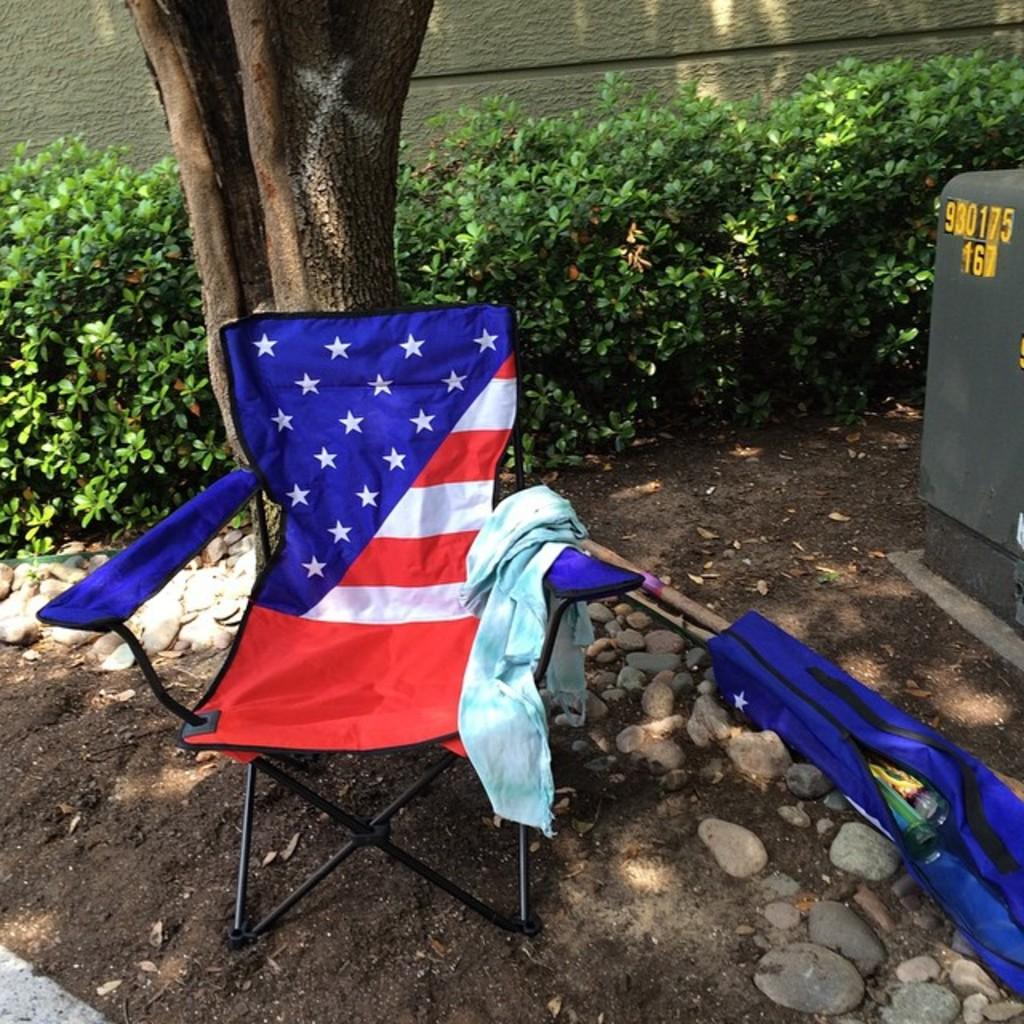What is located in the foreground of the image? In the foreground of the image, there is a chair, cloth, a box, plants, a tree trunk, and a wall. Can you describe the objects in the foreground? The chair is likely for sitting, the cloth could be a tablecloth or fabric, the box is a container, the plants are living organisms, the tree trunk is a part of a tree, and the wall is a vertical structure. What might be the setting of the image? The image may have been taken in a garden, as there are plants and a tree trunk present. What time of day is it in the image, and what type of plantation is visible? The time of day cannot be determined from the image, and there is no plantation visible. Is there a van parked in the foreground of the image? No, there is no van present in the image. 